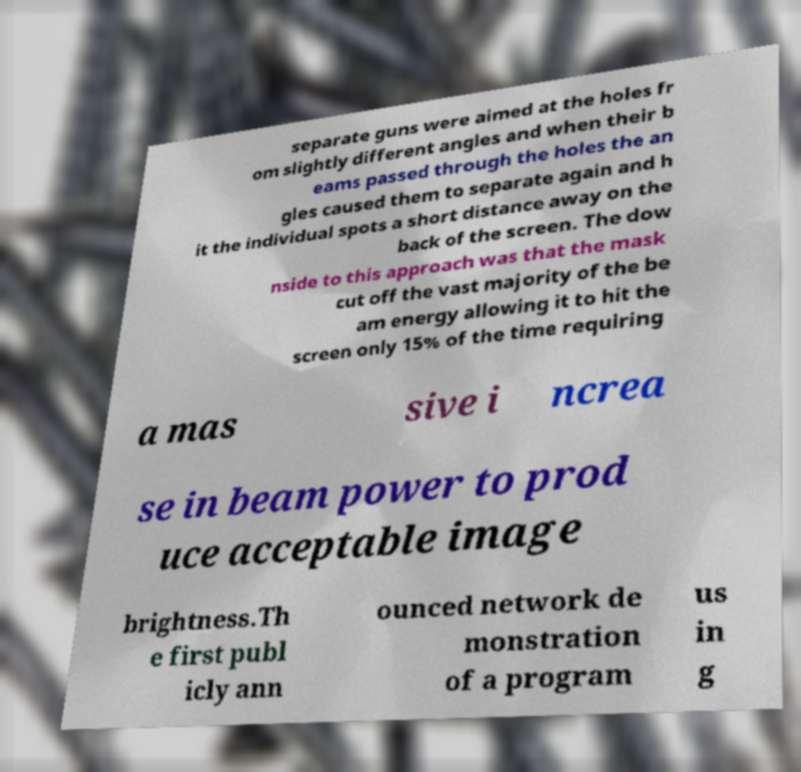Please identify and transcribe the text found in this image. separate guns were aimed at the holes fr om slightly different angles and when their b eams passed through the holes the an gles caused them to separate again and h it the individual spots a short distance away on the back of the screen. The dow nside to this approach was that the mask cut off the vast majority of the be am energy allowing it to hit the screen only 15% of the time requiring a mas sive i ncrea se in beam power to prod uce acceptable image brightness.Th e first publ icly ann ounced network de monstration of a program us in g 